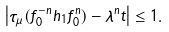Convert formula to latex. <formula><loc_0><loc_0><loc_500><loc_500>\left | \tau _ { \mu } ( f _ { 0 } ^ { - n } h _ { 1 } f _ { 0 } ^ { n } ) - \lambda ^ { n } t \right | \leq 1 .</formula> 